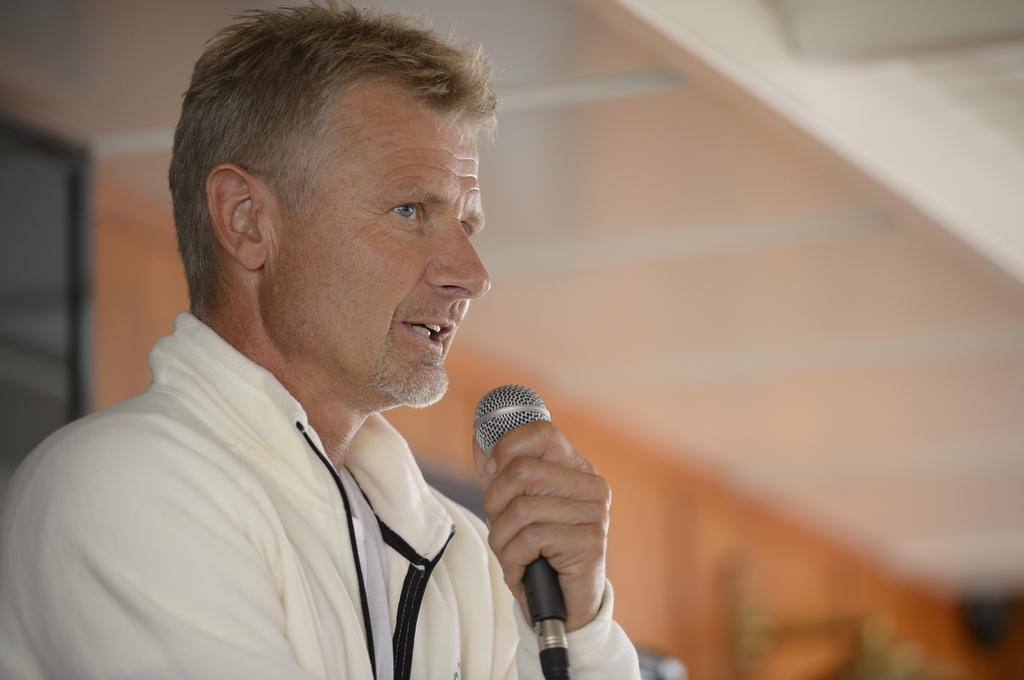What is the main subject of the image? There is a person in the image. What is the person holding in the image? The person is holding a microphone. How many pizzas are being served on the faucet in the image? There are no pizzas or faucets present in the image. 